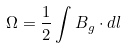Convert formula to latex. <formula><loc_0><loc_0><loc_500><loc_500>\Omega = \frac { 1 } { 2 } \int { B } _ { g } \cdot d { l }</formula> 